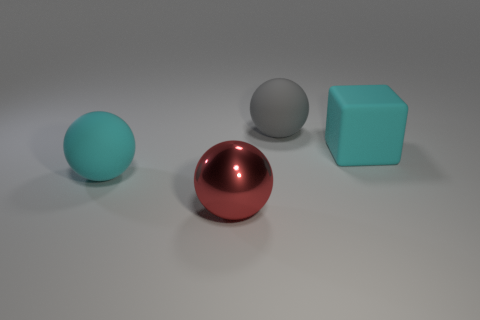What is the size of the other shiny object that is the same shape as the big gray thing?
Ensure brevity in your answer.  Large. Is the number of balls that are right of the large gray rubber ball greater than the number of cyan matte things behind the large cyan rubber block?
Give a very brief answer. No. Are the large gray ball and the big thing that is to the left of the red object made of the same material?
Offer a very short reply. Yes. Are there any other things that are the same shape as the gray rubber thing?
Your answer should be very brief. Yes. The big ball that is on the right side of the large cyan sphere and in front of the cube is what color?
Provide a succinct answer. Red. There is a big rubber object to the left of the big gray thing; what is its shape?
Give a very brief answer. Sphere. There is a cyan sphere left of the object that is in front of the big cyan thing that is to the left of the large gray ball; how big is it?
Give a very brief answer. Large. How many cyan rubber objects are behind the cyan matte object in front of the cube?
Give a very brief answer. 1. What size is the matte object that is both on the right side of the big red thing and in front of the gray sphere?
Your answer should be very brief. Large. What number of metallic things are big brown cubes or big cyan balls?
Provide a short and direct response. 0. 